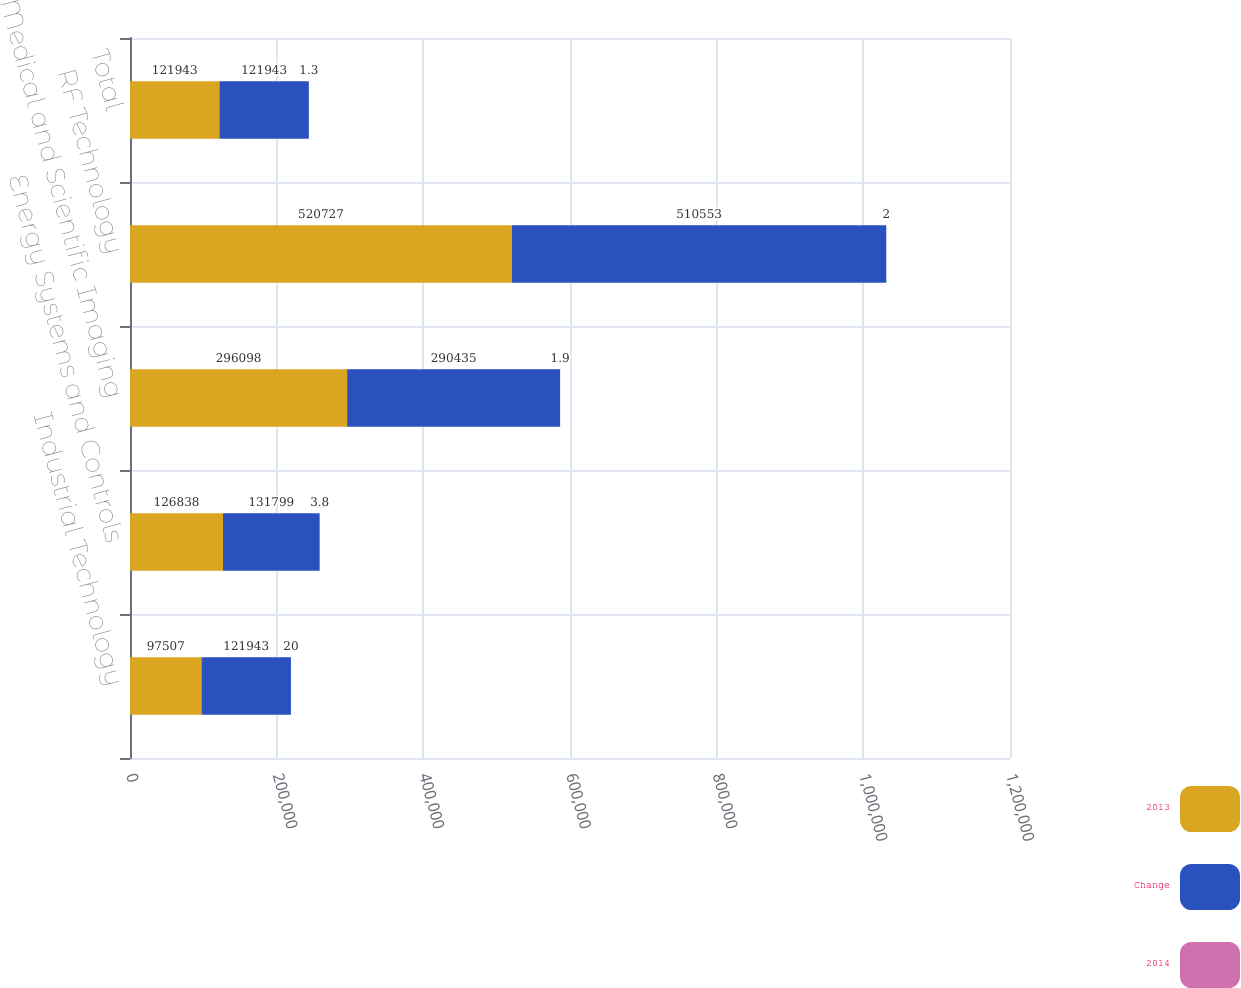Convert chart to OTSL. <chart><loc_0><loc_0><loc_500><loc_500><stacked_bar_chart><ecel><fcel>Industrial Technology<fcel>Energy Systems and Controls<fcel>Medical and Scientific Imaging<fcel>RF Technology<fcel>Total<nl><fcel>2013<fcel>97507<fcel>126838<fcel>296098<fcel>520727<fcel>121943<nl><fcel>Change<fcel>121943<fcel>131799<fcel>290435<fcel>510553<fcel>121943<nl><fcel>2014<fcel>20<fcel>3.8<fcel>1.9<fcel>2<fcel>1.3<nl></chart> 